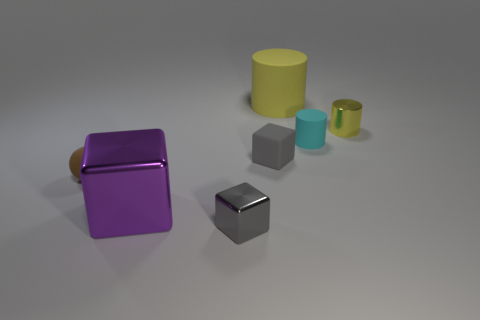Does the thing that is in front of the purple metallic block have the same color as the block that is behind the small brown rubber ball?
Provide a short and direct response. Yes. Is the number of small yellow things behind the small gray rubber block greater than the number of cyan metallic cylinders?
Provide a succinct answer. Yes. What number of other objects are the same color as the large cylinder?
Provide a succinct answer. 1. Do the object that is on the right side of the cyan matte object and the small gray metallic cube have the same size?
Offer a terse response. Yes. Is there a purple thing that has the same size as the yellow matte cylinder?
Give a very brief answer. Yes. The small cube that is to the right of the gray metal block is what color?
Offer a very short reply. Gray. What is the shape of the object that is behind the tiny cyan rubber cylinder and in front of the big yellow object?
Ensure brevity in your answer.  Cylinder. What number of large yellow things are the same shape as the small cyan thing?
Give a very brief answer. 1. What number of big purple metal cylinders are there?
Offer a very short reply. 0. How big is the thing that is both on the left side of the tiny metallic cube and behind the large purple shiny thing?
Your answer should be very brief. Small. 